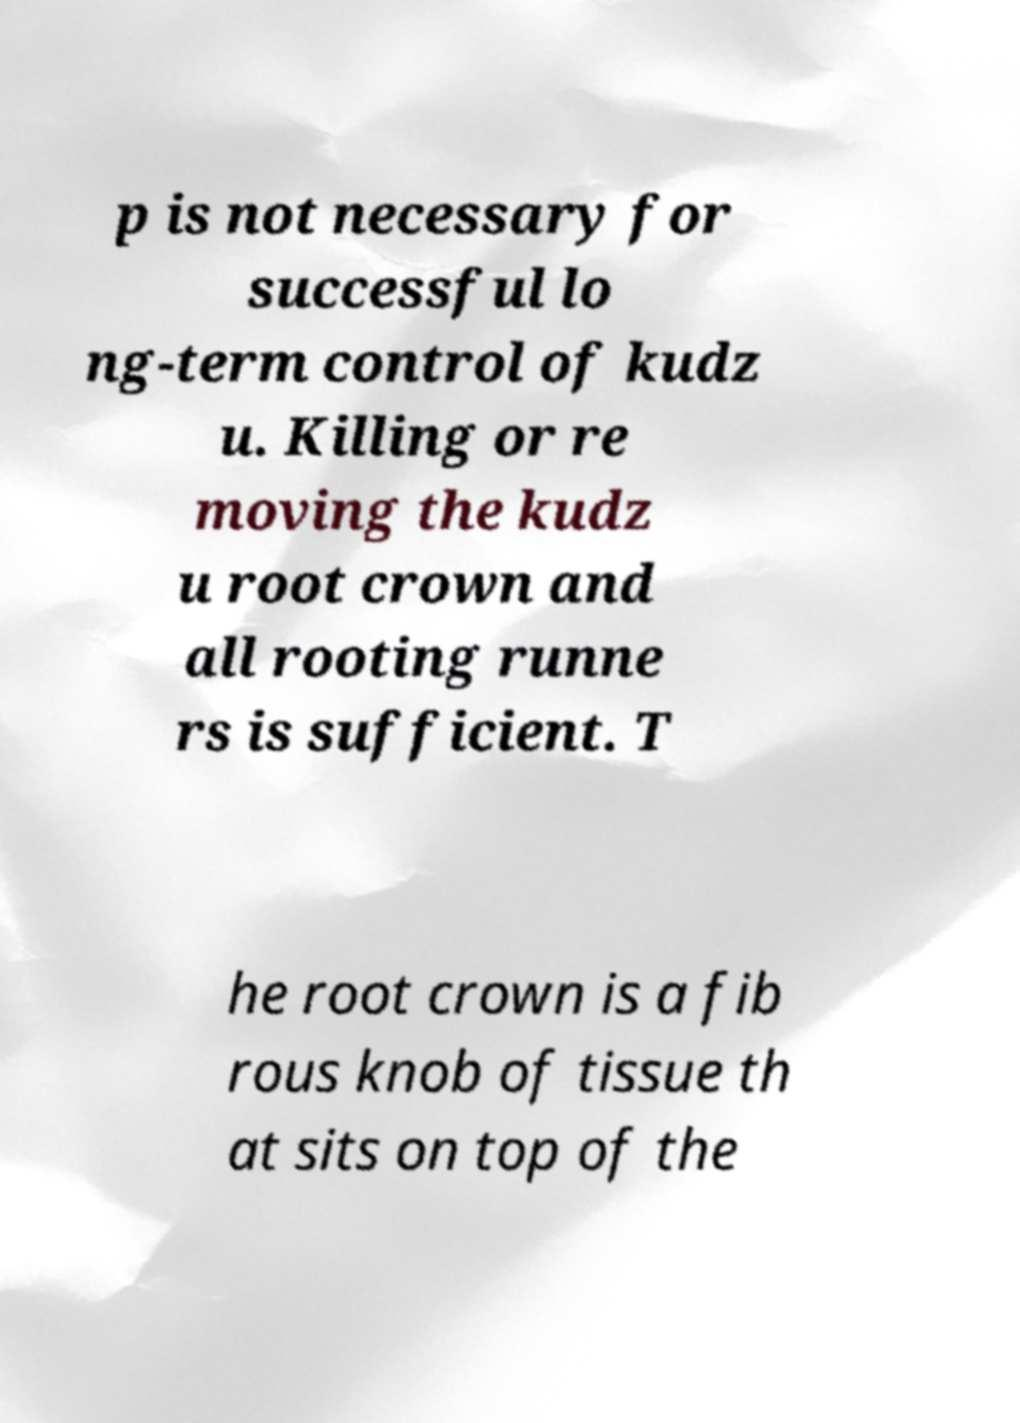Could you assist in decoding the text presented in this image and type it out clearly? p is not necessary for successful lo ng-term control of kudz u. Killing or re moving the kudz u root crown and all rooting runne rs is sufficient. T he root crown is a fib rous knob of tissue th at sits on top of the 